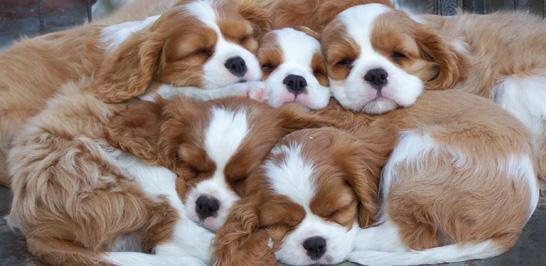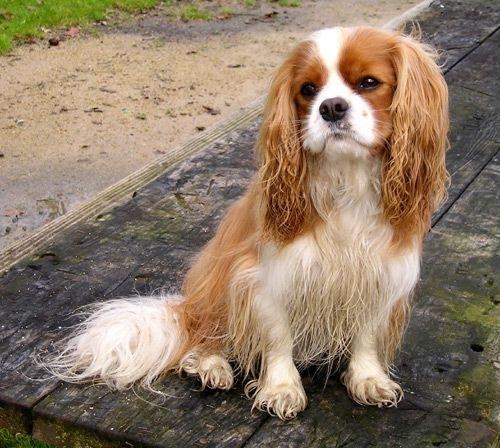The first image is the image on the left, the second image is the image on the right. For the images shown, is this caption "One of the images contains exactly two puppies." true? Answer yes or no. No. 